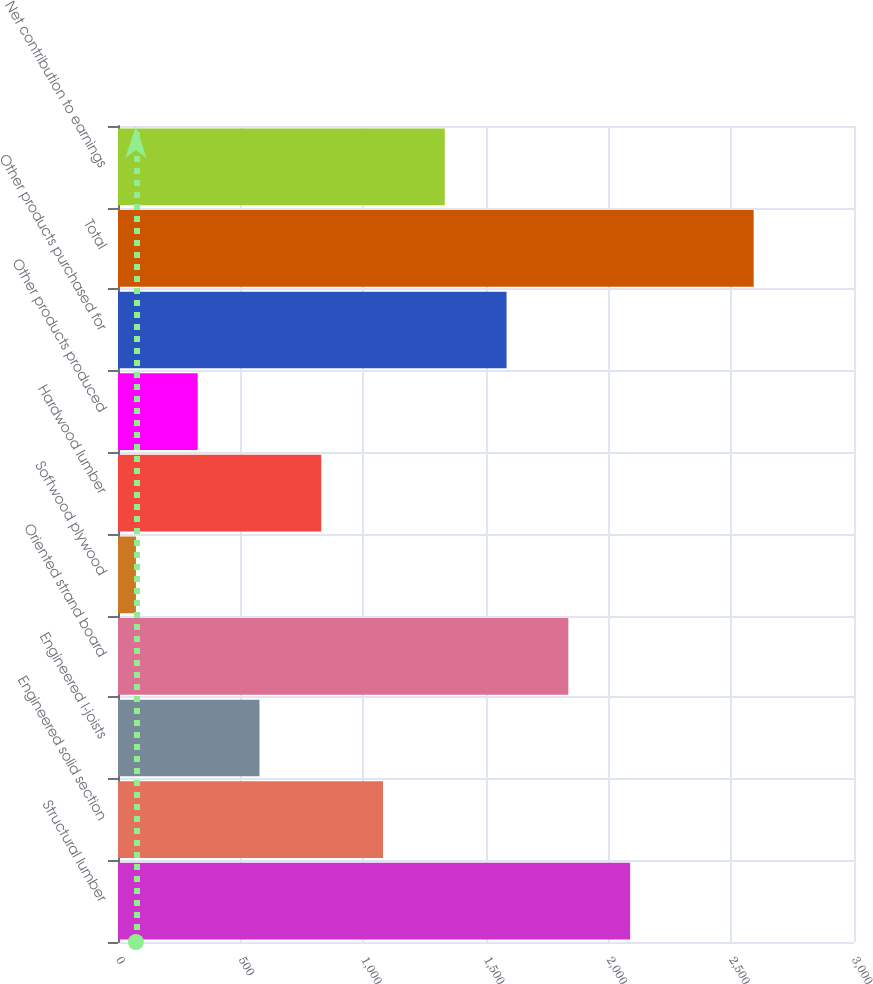<chart> <loc_0><loc_0><loc_500><loc_500><bar_chart><fcel>Structural lumber<fcel>Engineered solid section<fcel>Engineered I-joists<fcel>Oriented strand board<fcel>Softwood plywood<fcel>Hardwood lumber<fcel>Other products produced<fcel>Other products purchased for<fcel>Total<fcel>Net contribution to earnings<nl><fcel>2087.4<fcel>1080.2<fcel>576.6<fcel>1835.6<fcel>73<fcel>828.4<fcel>324.8<fcel>1583.8<fcel>2591<fcel>1332<nl></chart> 